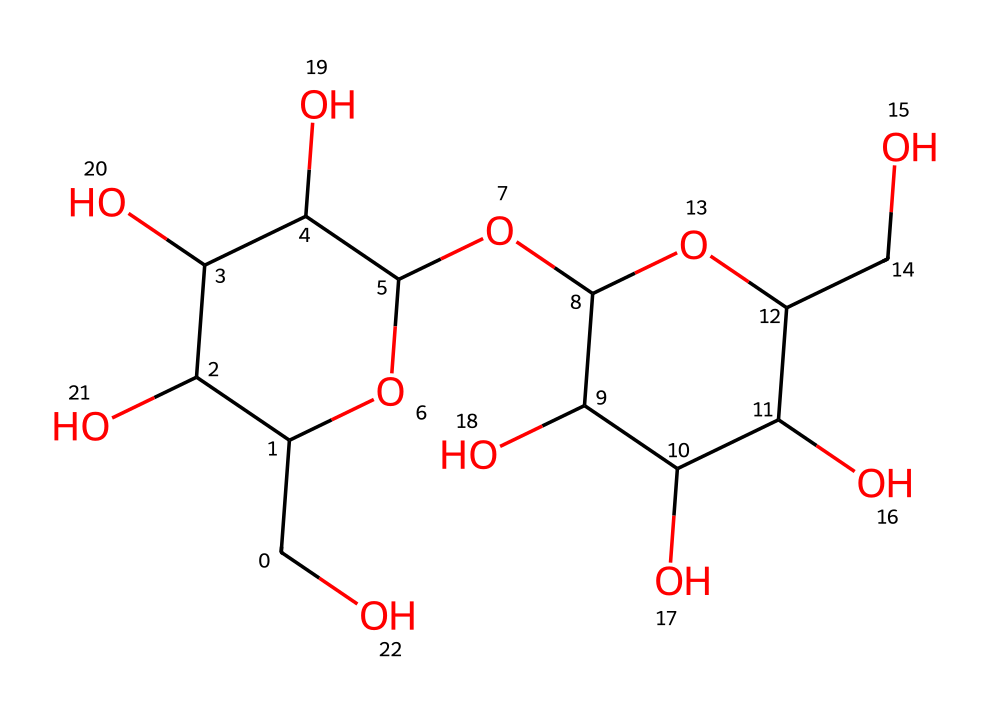What is the primary function of glycogen in animals? Glycogen serves as the primary storage form of glucose in animals, providing energy when needed.
Answer: energy storage How many rings are present in this structure? The structure shows two cyclic forms (rings) of glucose units, indicating that it contains two rings.
Answer: two What type of carbohydrate is glycogen? Glycogen is a polysaccharide, as it consists of many glucose units linked together.
Answer: polysaccharide How many hydroxyl groups (-OH) are found in this structure? By counting the "-OH" groups present in the given SMILES representation, there are a total of ten hydroxyl groups in glycogen.
Answer: ten Describe the main structural feature that distinguishes glycogen from starch. Glycogen has a more branched structure compared to starch, with shorter chains and more frequent branching points.
Answer: branched structure What predominant monosaccharide unit composes glycogen? Glycogen is primarily composed of glucose units, which are the individual monosaccharides linked together.
Answer: glucose 